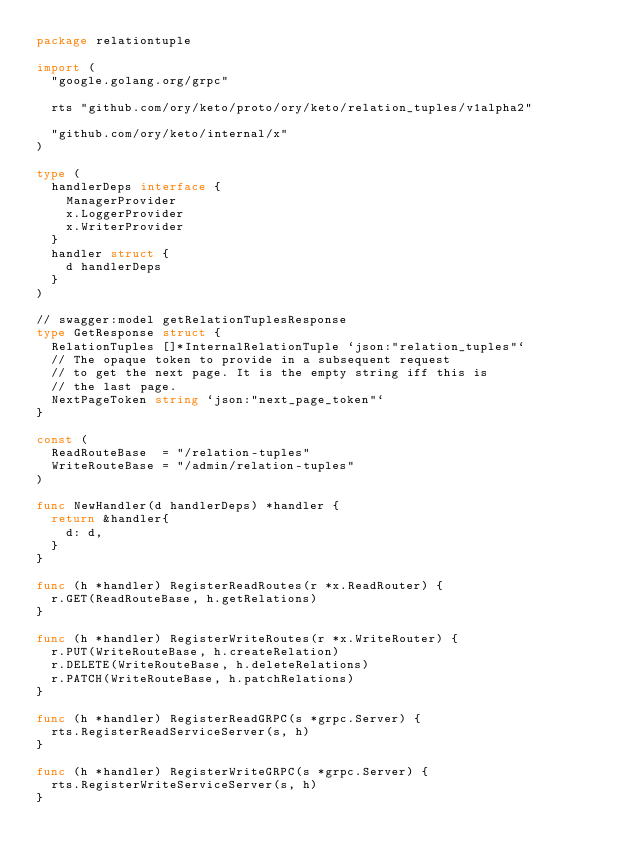Convert code to text. <code><loc_0><loc_0><loc_500><loc_500><_Go_>package relationtuple

import (
	"google.golang.org/grpc"

	rts "github.com/ory/keto/proto/ory/keto/relation_tuples/v1alpha2"

	"github.com/ory/keto/internal/x"
)

type (
	handlerDeps interface {
		ManagerProvider
		x.LoggerProvider
		x.WriterProvider
	}
	handler struct {
		d handlerDeps
	}
)

// swagger:model getRelationTuplesResponse
type GetResponse struct {
	RelationTuples []*InternalRelationTuple `json:"relation_tuples"`
	// The opaque token to provide in a subsequent request
	// to get the next page. It is the empty string iff this is
	// the last page.
	NextPageToken string `json:"next_page_token"`
}

const (
	ReadRouteBase  = "/relation-tuples"
	WriteRouteBase = "/admin/relation-tuples"
)

func NewHandler(d handlerDeps) *handler {
	return &handler{
		d: d,
	}
}

func (h *handler) RegisterReadRoutes(r *x.ReadRouter) {
	r.GET(ReadRouteBase, h.getRelations)
}

func (h *handler) RegisterWriteRoutes(r *x.WriteRouter) {
	r.PUT(WriteRouteBase, h.createRelation)
	r.DELETE(WriteRouteBase, h.deleteRelations)
	r.PATCH(WriteRouteBase, h.patchRelations)
}

func (h *handler) RegisterReadGRPC(s *grpc.Server) {
	rts.RegisterReadServiceServer(s, h)
}

func (h *handler) RegisterWriteGRPC(s *grpc.Server) {
	rts.RegisterWriteServiceServer(s, h)
}
</code> 